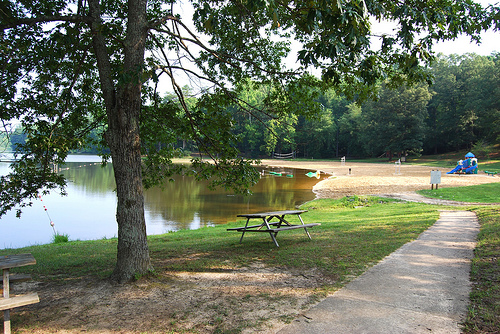<image>
Is the tree on the water? No. The tree is not positioned on the water. They may be near each other, but the tree is not supported by or resting on top of the water. 